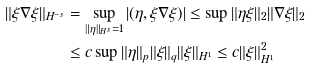Convert formula to latex. <formula><loc_0><loc_0><loc_500><loc_500>\| \xi \nabla \xi \| _ { H ^ { - s } } & = \sup _ { \| \eta \| _ { H ^ { s } } = 1 } | ( \eta , \xi \nabla \xi ) | \leq \sup \| \eta \xi \| _ { 2 } \| \nabla \xi \| _ { 2 } \\ & \leq c \sup \| \eta \| _ { p } \| \xi \| _ { q } \| \xi \| _ { H ^ { 1 } } \leq c \| \xi \| _ { H ^ { 1 } } ^ { 2 }</formula> 